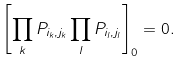<formula> <loc_0><loc_0><loc_500><loc_500>\left [ \prod _ { k } P _ { i _ { k } , j _ { k } } \prod _ { l } P _ { i _ { l } , j _ { l } } \right ] _ { 0 } = 0 .</formula> 